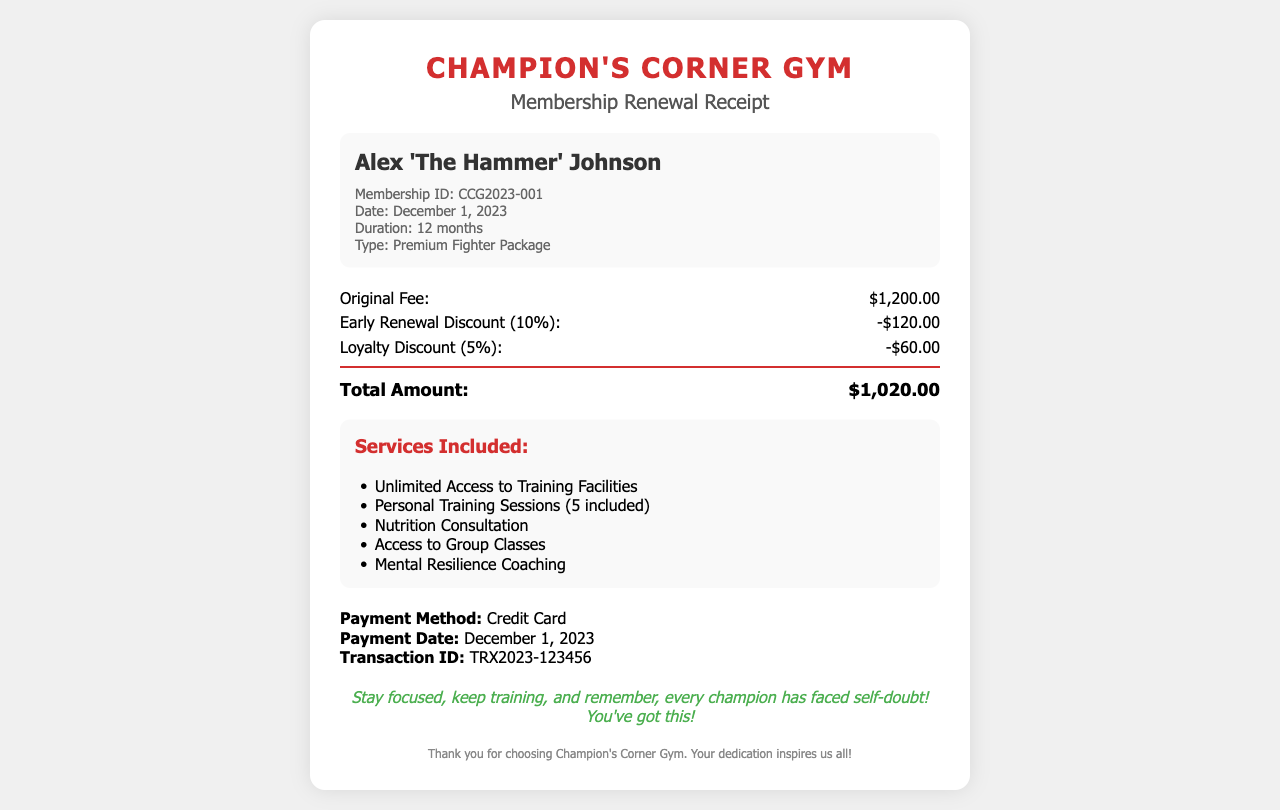What is the member's name? The member's name is indicated prominently in the document, specifically in the member-info section.
Answer: Alex 'The Hammer' Johnson What is the membership ID? The membership ID is provided in the membership details.
Answer: CCG2023-001 What is the total amount after discounts? The total amount is a result of subtracting the discounts from the original fee, shown in the fee breakdown section.
Answer: $1,020.00 What discounts were applied? The document lists two discounts: an early renewal discount and a loyalty discount.
Answer: 10%, 5% What type of membership is this receipt for? The type of membership is specified in the membership details section of the document.
Answer: Premium Fighter Package What services are included? The list of services is detailed under the "Services Included" heading.
Answer: Unlimited Access to Training Facilities, Personal Training Sessions (5 included), Nutrition Consultation, Access to Group Classes, Mental Resilience Coaching What was the payment method? The payment method is explicitly stated in the payment info section of the receipt.
Answer: Credit Card When was the payment made? The payment date is clearly mentioned in the payment info area of the receipt.
Answer: December 1, 2023 What is the advice given at the bottom? The advice is an encouraging statement meant for the member, found under the advice section.
Answer: Stay focused, keep training, and remember, every champion has faced self-doubt! You've got this! 